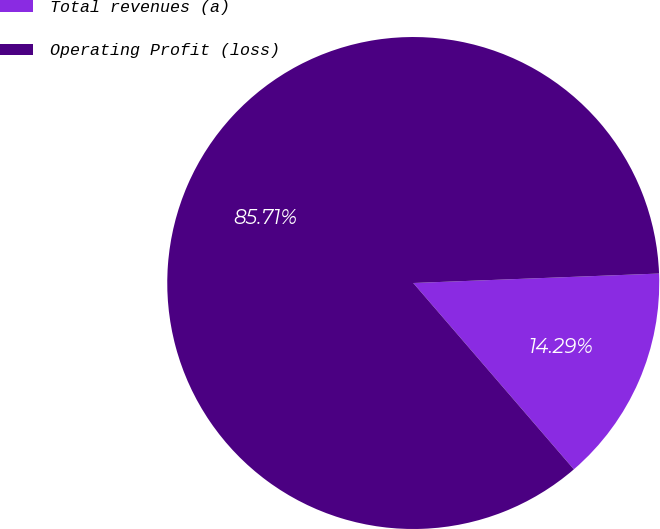Convert chart. <chart><loc_0><loc_0><loc_500><loc_500><pie_chart><fcel>Total revenues (a)<fcel>Operating Profit (loss)<nl><fcel>14.29%<fcel>85.71%<nl></chart> 